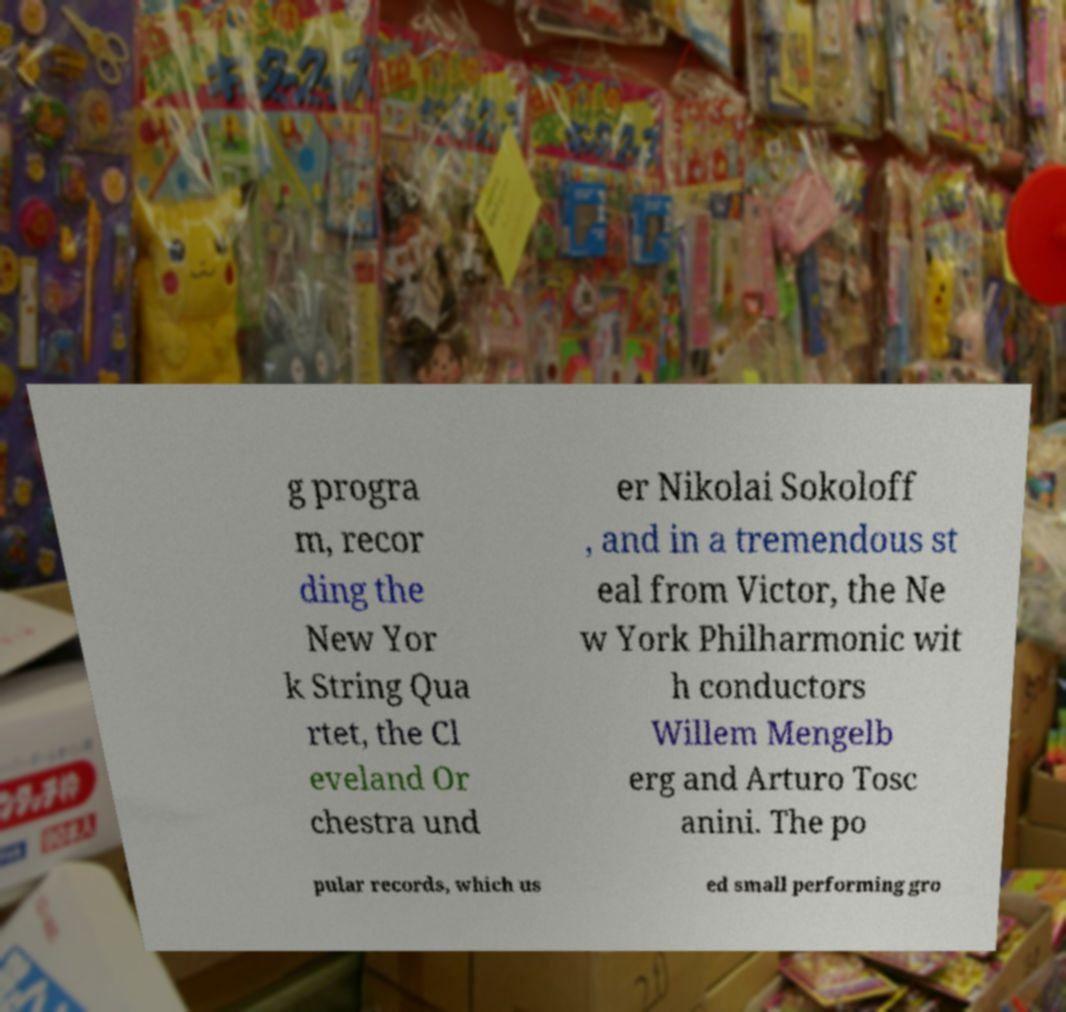Please read and relay the text visible in this image. What does it say? g progra m, recor ding the New Yor k String Qua rtet, the Cl eveland Or chestra und er Nikolai Sokoloff , and in a tremendous st eal from Victor, the Ne w York Philharmonic wit h conductors Willem Mengelb erg and Arturo Tosc anini. The po pular records, which us ed small performing gro 